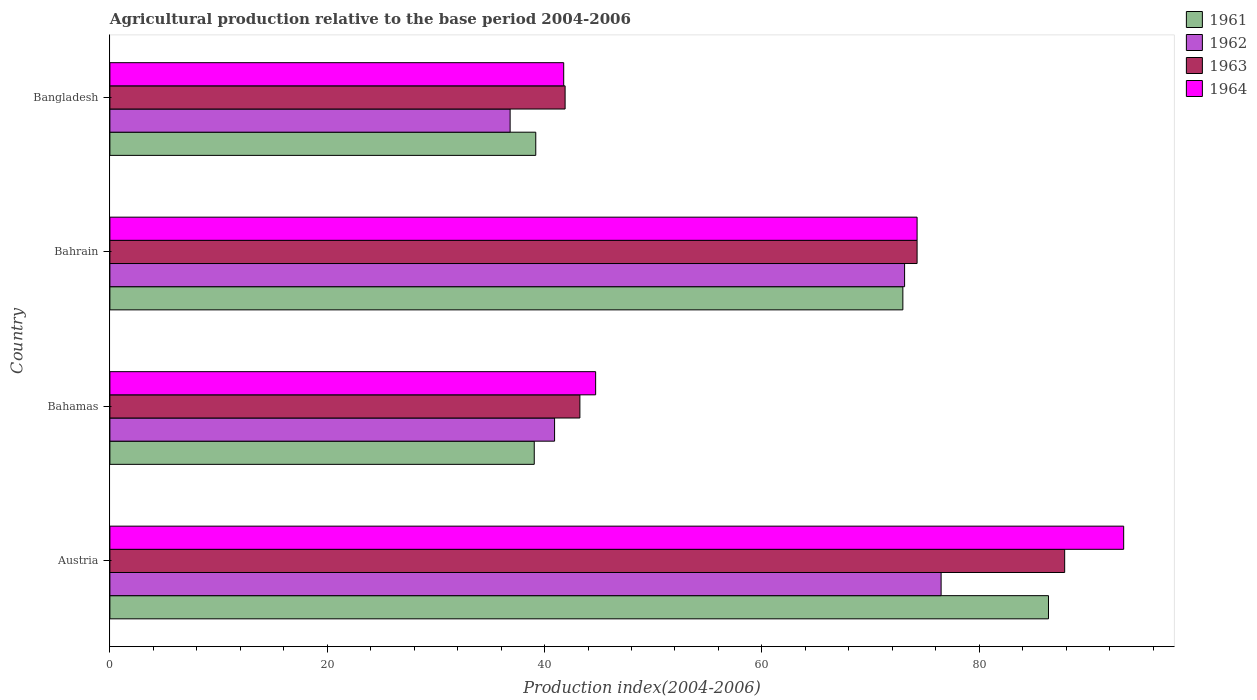How many different coloured bars are there?
Ensure brevity in your answer.  4. How many bars are there on the 4th tick from the top?
Offer a terse response. 4. What is the label of the 3rd group of bars from the top?
Give a very brief answer. Bahamas. In how many cases, is the number of bars for a given country not equal to the number of legend labels?
Make the answer very short. 0. What is the agricultural production index in 1963 in Bangladesh?
Provide a succinct answer. 41.89. Across all countries, what is the maximum agricultural production index in 1961?
Provide a succinct answer. 86.37. Across all countries, what is the minimum agricultural production index in 1964?
Provide a short and direct response. 41.76. In which country was the agricultural production index in 1963 maximum?
Offer a terse response. Austria. What is the total agricultural production index in 1964 in the graph?
Your answer should be very brief. 254.03. What is the difference between the agricultural production index in 1962 in Bahrain and that in Bangladesh?
Your answer should be very brief. 36.3. What is the difference between the agricultural production index in 1962 in Austria and the agricultural production index in 1963 in Bahamas?
Ensure brevity in your answer.  33.24. What is the average agricultural production index in 1962 per country?
Offer a terse response. 56.84. What is the difference between the agricultural production index in 1961 and agricultural production index in 1964 in Austria?
Provide a succinct answer. -6.92. What is the ratio of the agricultural production index in 1963 in Bahamas to that in Bahrain?
Offer a very short reply. 0.58. What is the difference between the highest and the second highest agricultural production index in 1961?
Provide a short and direct response. 13.4. What is the difference between the highest and the lowest agricultural production index in 1961?
Provide a succinct answer. 47.32. In how many countries, is the agricultural production index in 1963 greater than the average agricultural production index in 1963 taken over all countries?
Offer a terse response. 2. What does the 4th bar from the bottom in Bahrain represents?
Your answer should be compact. 1964. Does the graph contain any zero values?
Offer a very short reply. No. Where does the legend appear in the graph?
Your answer should be very brief. Top right. What is the title of the graph?
Give a very brief answer. Agricultural production relative to the base period 2004-2006. What is the label or title of the X-axis?
Provide a succinct answer. Production index(2004-2006). What is the label or title of the Y-axis?
Make the answer very short. Country. What is the Production index(2004-2006) in 1961 in Austria?
Offer a very short reply. 86.37. What is the Production index(2004-2006) in 1962 in Austria?
Offer a terse response. 76.49. What is the Production index(2004-2006) in 1963 in Austria?
Make the answer very short. 87.86. What is the Production index(2004-2006) of 1964 in Austria?
Offer a very short reply. 93.29. What is the Production index(2004-2006) of 1961 in Bahamas?
Give a very brief answer. 39.05. What is the Production index(2004-2006) of 1962 in Bahamas?
Ensure brevity in your answer.  40.92. What is the Production index(2004-2006) of 1963 in Bahamas?
Offer a terse response. 43.25. What is the Production index(2004-2006) of 1964 in Bahamas?
Provide a succinct answer. 44.7. What is the Production index(2004-2006) of 1961 in Bahrain?
Your answer should be very brief. 72.97. What is the Production index(2004-2006) in 1962 in Bahrain?
Provide a short and direct response. 73.13. What is the Production index(2004-2006) of 1963 in Bahrain?
Provide a short and direct response. 74.28. What is the Production index(2004-2006) in 1964 in Bahrain?
Your answer should be very brief. 74.28. What is the Production index(2004-2006) of 1961 in Bangladesh?
Provide a succinct answer. 39.19. What is the Production index(2004-2006) in 1962 in Bangladesh?
Make the answer very short. 36.83. What is the Production index(2004-2006) of 1963 in Bangladesh?
Your answer should be compact. 41.89. What is the Production index(2004-2006) of 1964 in Bangladesh?
Provide a short and direct response. 41.76. Across all countries, what is the maximum Production index(2004-2006) of 1961?
Provide a succinct answer. 86.37. Across all countries, what is the maximum Production index(2004-2006) in 1962?
Give a very brief answer. 76.49. Across all countries, what is the maximum Production index(2004-2006) of 1963?
Offer a very short reply. 87.86. Across all countries, what is the maximum Production index(2004-2006) in 1964?
Your response must be concise. 93.29. Across all countries, what is the minimum Production index(2004-2006) of 1961?
Provide a short and direct response. 39.05. Across all countries, what is the minimum Production index(2004-2006) of 1962?
Offer a very short reply. 36.83. Across all countries, what is the minimum Production index(2004-2006) in 1963?
Offer a terse response. 41.89. Across all countries, what is the minimum Production index(2004-2006) of 1964?
Provide a succinct answer. 41.76. What is the total Production index(2004-2006) of 1961 in the graph?
Provide a succinct answer. 237.58. What is the total Production index(2004-2006) in 1962 in the graph?
Your answer should be very brief. 227.37. What is the total Production index(2004-2006) in 1963 in the graph?
Give a very brief answer. 247.28. What is the total Production index(2004-2006) in 1964 in the graph?
Offer a terse response. 254.03. What is the difference between the Production index(2004-2006) of 1961 in Austria and that in Bahamas?
Ensure brevity in your answer.  47.32. What is the difference between the Production index(2004-2006) of 1962 in Austria and that in Bahamas?
Give a very brief answer. 35.57. What is the difference between the Production index(2004-2006) of 1963 in Austria and that in Bahamas?
Make the answer very short. 44.61. What is the difference between the Production index(2004-2006) in 1964 in Austria and that in Bahamas?
Your answer should be very brief. 48.59. What is the difference between the Production index(2004-2006) in 1962 in Austria and that in Bahrain?
Keep it short and to the point. 3.36. What is the difference between the Production index(2004-2006) in 1963 in Austria and that in Bahrain?
Make the answer very short. 13.58. What is the difference between the Production index(2004-2006) in 1964 in Austria and that in Bahrain?
Your response must be concise. 19.01. What is the difference between the Production index(2004-2006) of 1961 in Austria and that in Bangladesh?
Give a very brief answer. 47.18. What is the difference between the Production index(2004-2006) in 1962 in Austria and that in Bangladesh?
Give a very brief answer. 39.66. What is the difference between the Production index(2004-2006) of 1963 in Austria and that in Bangladesh?
Your answer should be very brief. 45.97. What is the difference between the Production index(2004-2006) in 1964 in Austria and that in Bangladesh?
Ensure brevity in your answer.  51.53. What is the difference between the Production index(2004-2006) in 1961 in Bahamas and that in Bahrain?
Keep it short and to the point. -33.92. What is the difference between the Production index(2004-2006) of 1962 in Bahamas and that in Bahrain?
Provide a short and direct response. -32.21. What is the difference between the Production index(2004-2006) of 1963 in Bahamas and that in Bahrain?
Your answer should be very brief. -31.03. What is the difference between the Production index(2004-2006) of 1964 in Bahamas and that in Bahrain?
Your answer should be compact. -29.58. What is the difference between the Production index(2004-2006) in 1961 in Bahamas and that in Bangladesh?
Offer a very short reply. -0.14. What is the difference between the Production index(2004-2006) in 1962 in Bahamas and that in Bangladesh?
Provide a short and direct response. 4.09. What is the difference between the Production index(2004-2006) of 1963 in Bahamas and that in Bangladesh?
Make the answer very short. 1.36. What is the difference between the Production index(2004-2006) in 1964 in Bahamas and that in Bangladesh?
Your response must be concise. 2.94. What is the difference between the Production index(2004-2006) in 1961 in Bahrain and that in Bangladesh?
Your answer should be compact. 33.78. What is the difference between the Production index(2004-2006) in 1962 in Bahrain and that in Bangladesh?
Offer a very short reply. 36.3. What is the difference between the Production index(2004-2006) in 1963 in Bahrain and that in Bangladesh?
Offer a very short reply. 32.39. What is the difference between the Production index(2004-2006) of 1964 in Bahrain and that in Bangladesh?
Offer a terse response. 32.52. What is the difference between the Production index(2004-2006) of 1961 in Austria and the Production index(2004-2006) of 1962 in Bahamas?
Offer a very short reply. 45.45. What is the difference between the Production index(2004-2006) in 1961 in Austria and the Production index(2004-2006) in 1963 in Bahamas?
Offer a terse response. 43.12. What is the difference between the Production index(2004-2006) of 1961 in Austria and the Production index(2004-2006) of 1964 in Bahamas?
Provide a succinct answer. 41.67. What is the difference between the Production index(2004-2006) of 1962 in Austria and the Production index(2004-2006) of 1963 in Bahamas?
Ensure brevity in your answer.  33.24. What is the difference between the Production index(2004-2006) in 1962 in Austria and the Production index(2004-2006) in 1964 in Bahamas?
Your response must be concise. 31.79. What is the difference between the Production index(2004-2006) of 1963 in Austria and the Production index(2004-2006) of 1964 in Bahamas?
Ensure brevity in your answer.  43.16. What is the difference between the Production index(2004-2006) in 1961 in Austria and the Production index(2004-2006) in 1962 in Bahrain?
Your answer should be very brief. 13.24. What is the difference between the Production index(2004-2006) in 1961 in Austria and the Production index(2004-2006) in 1963 in Bahrain?
Offer a terse response. 12.09. What is the difference between the Production index(2004-2006) of 1961 in Austria and the Production index(2004-2006) of 1964 in Bahrain?
Give a very brief answer. 12.09. What is the difference between the Production index(2004-2006) in 1962 in Austria and the Production index(2004-2006) in 1963 in Bahrain?
Your response must be concise. 2.21. What is the difference between the Production index(2004-2006) of 1962 in Austria and the Production index(2004-2006) of 1964 in Bahrain?
Give a very brief answer. 2.21. What is the difference between the Production index(2004-2006) of 1963 in Austria and the Production index(2004-2006) of 1964 in Bahrain?
Your response must be concise. 13.58. What is the difference between the Production index(2004-2006) of 1961 in Austria and the Production index(2004-2006) of 1962 in Bangladesh?
Provide a succinct answer. 49.54. What is the difference between the Production index(2004-2006) of 1961 in Austria and the Production index(2004-2006) of 1963 in Bangladesh?
Keep it short and to the point. 44.48. What is the difference between the Production index(2004-2006) of 1961 in Austria and the Production index(2004-2006) of 1964 in Bangladesh?
Offer a very short reply. 44.61. What is the difference between the Production index(2004-2006) of 1962 in Austria and the Production index(2004-2006) of 1963 in Bangladesh?
Keep it short and to the point. 34.6. What is the difference between the Production index(2004-2006) of 1962 in Austria and the Production index(2004-2006) of 1964 in Bangladesh?
Give a very brief answer. 34.73. What is the difference between the Production index(2004-2006) in 1963 in Austria and the Production index(2004-2006) in 1964 in Bangladesh?
Offer a very short reply. 46.1. What is the difference between the Production index(2004-2006) in 1961 in Bahamas and the Production index(2004-2006) in 1962 in Bahrain?
Offer a terse response. -34.08. What is the difference between the Production index(2004-2006) in 1961 in Bahamas and the Production index(2004-2006) in 1963 in Bahrain?
Keep it short and to the point. -35.23. What is the difference between the Production index(2004-2006) in 1961 in Bahamas and the Production index(2004-2006) in 1964 in Bahrain?
Offer a very short reply. -35.23. What is the difference between the Production index(2004-2006) of 1962 in Bahamas and the Production index(2004-2006) of 1963 in Bahrain?
Your answer should be very brief. -33.36. What is the difference between the Production index(2004-2006) in 1962 in Bahamas and the Production index(2004-2006) in 1964 in Bahrain?
Offer a terse response. -33.36. What is the difference between the Production index(2004-2006) of 1963 in Bahamas and the Production index(2004-2006) of 1964 in Bahrain?
Ensure brevity in your answer.  -31.03. What is the difference between the Production index(2004-2006) of 1961 in Bahamas and the Production index(2004-2006) of 1962 in Bangladesh?
Provide a succinct answer. 2.22. What is the difference between the Production index(2004-2006) in 1961 in Bahamas and the Production index(2004-2006) in 1963 in Bangladesh?
Make the answer very short. -2.84. What is the difference between the Production index(2004-2006) of 1961 in Bahamas and the Production index(2004-2006) of 1964 in Bangladesh?
Make the answer very short. -2.71. What is the difference between the Production index(2004-2006) of 1962 in Bahamas and the Production index(2004-2006) of 1963 in Bangladesh?
Give a very brief answer. -0.97. What is the difference between the Production index(2004-2006) of 1962 in Bahamas and the Production index(2004-2006) of 1964 in Bangladesh?
Offer a very short reply. -0.84. What is the difference between the Production index(2004-2006) in 1963 in Bahamas and the Production index(2004-2006) in 1964 in Bangladesh?
Offer a very short reply. 1.49. What is the difference between the Production index(2004-2006) of 1961 in Bahrain and the Production index(2004-2006) of 1962 in Bangladesh?
Your answer should be compact. 36.14. What is the difference between the Production index(2004-2006) in 1961 in Bahrain and the Production index(2004-2006) in 1963 in Bangladesh?
Your response must be concise. 31.08. What is the difference between the Production index(2004-2006) of 1961 in Bahrain and the Production index(2004-2006) of 1964 in Bangladesh?
Your response must be concise. 31.21. What is the difference between the Production index(2004-2006) of 1962 in Bahrain and the Production index(2004-2006) of 1963 in Bangladesh?
Offer a very short reply. 31.24. What is the difference between the Production index(2004-2006) of 1962 in Bahrain and the Production index(2004-2006) of 1964 in Bangladesh?
Provide a succinct answer. 31.37. What is the difference between the Production index(2004-2006) of 1963 in Bahrain and the Production index(2004-2006) of 1964 in Bangladesh?
Ensure brevity in your answer.  32.52. What is the average Production index(2004-2006) of 1961 per country?
Your answer should be compact. 59.4. What is the average Production index(2004-2006) in 1962 per country?
Your answer should be very brief. 56.84. What is the average Production index(2004-2006) of 1963 per country?
Give a very brief answer. 61.82. What is the average Production index(2004-2006) in 1964 per country?
Your answer should be compact. 63.51. What is the difference between the Production index(2004-2006) of 1961 and Production index(2004-2006) of 1962 in Austria?
Ensure brevity in your answer.  9.88. What is the difference between the Production index(2004-2006) in 1961 and Production index(2004-2006) in 1963 in Austria?
Ensure brevity in your answer.  -1.49. What is the difference between the Production index(2004-2006) in 1961 and Production index(2004-2006) in 1964 in Austria?
Provide a succinct answer. -6.92. What is the difference between the Production index(2004-2006) of 1962 and Production index(2004-2006) of 1963 in Austria?
Provide a succinct answer. -11.37. What is the difference between the Production index(2004-2006) in 1962 and Production index(2004-2006) in 1964 in Austria?
Keep it short and to the point. -16.8. What is the difference between the Production index(2004-2006) in 1963 and Production index(2004-2006) in 1964 in Austria?
Offer a very short reply. -5.43. What is the difference between the Production index(2004-2006) of 1961 and Production index(2004-2006) of 1962 in Bahamas?
Ensure brevity in your answer.  -1.87. What is the difference between the Production index(2004-2006) of 1961 and Production index(2004-2006) of 1963 in Bahamas?
Provide a succinct answer. -4.2. What is the difference between the Production index(2004-2006) in 1961 and Production index(2004-2006) in 1964 in Bahamas?
Your answer should be very brief. -5.65. What is the difference between the Production index(2004-2006) of 1962 and Production index(2004-2006) of 1963 in Bahamas?
Your answer should be compact. -2.33. What is the difference between the Production index(2004-2006) of 1962 and Production index(2004-2006) of 1964 in Bahamas?
Offer a very short reply. -3.78. What is the difference between the Production index(2004-2006) of 1963 and Production index(2004-2006) of 1964 in Bahamas?
Offer a terse response. -1.45. What is the difference between the Production index(2004-2006) in 1961 and Production index(2004-2006) in 1962 in Bahrain?
Provide a short and direct response. -0.16. What is the difference between the Production index(2004-2006) in 1961 and Production index(2004-2006) in 1963 in Bahrain?
Your answer should be very brief. -1.31. What is the difference between the Production index(2004-2006) in 1961 and Production index(2004-2006) in 1964 in Bahrain?
Make the answer very short. -1.31. What is the difference between the Production index(2004-2006) in 1962 and Production index(2004-2006) in 1963 in Bahrain?
Your answer should be compact. -1.15. What is the difference between the Production index(2004-2006) of 1962 and Production index(2004-2006) of 1964 in Bahrain?
Offer a very short reply. -1.15. What is the difference between the Production index(2004-2006) in 1963 and Production index(2004-2006) in 1964 in Bahrain?
Offer a terse response. 0. What is the difference between the Production index(2004-2006) of 1961 and Production index(2004-2006) of 1962 in Bangladesh?
Offer a very short reply. 2.36. What is the difference between the Production index(2004-2006) of 1961 and Production index(2004-2006) of 1963 in Bangladesh?
Make the answer very short. -2.7. What is the difference between the Production index(2004-2006) of 1961 and Production index(2004-2006) of 1964 in Bangladesh?
Offer a terse response. -2.57. What is the difference between the Production index(2004-2006) in 1962 and Production index(2004-2006) in 1963 in Bangladesh?
Provide a short and direct response. -5.06. What is the difference between the Production index(2004-2006) in 1962 and Production index(2004-2006) in 1964 in Bangladesh?
Keep it short and to the point. -4.93. What is the difference between the Production index(2004-2006) in 1963 and Production index(2004-2006) in 1964 in Bangladesh?
Your response must be concise. 0.13. What is the ratio of the Production index(2004-2006) in 1961 in Austria to that in Bahamas?
Offer a very short reply. 2.21. What is the ratio of the Production index(2004-2006) in 1962 in Austria to that in Bahamas?
Ensure brevity in your answer.  1.87. What is the ratio of the Production index(2004-2006) in 1963 in Austria to that in Bahamas?
Keep it short and to the point. 2.03. What is the ratio of the Production index(2004-2006) of 1964 in Austria to that in Bahamas?
Your answer should be very brief. 2.09. What is the ratio of the Production index(2004-2006) in 1961 in Austria to that in Bahrain?
Offer a very short reply. 1.18. What is the ratio of the Production index(2004-2006) in 1962 in Austria to that in Bahrain?
Offer a very short reply. 1.05. What is the ratio of the Production index(2004-2006) of 1963 in Austria to that in Bahrain?
Provide a succinct answer. 1.18. What is the ratio of the Production index(2004-2006) in 1964 in Austria to that in Bahrain?
Give a very brief answer. 1.26. What is the ratio of the Production index(2004-2006) in 1961 in Austria to that in Bangladesh?
Keep it short and to the point. 2.2. What is the ratio of the Production index(2004-2006) in 1962 in Austria to that in Bangladesh?
Provide a short and direct response. 2.08. What is the ratio of the Production index(2004-2006) of 1963 in Austria to that in Bangladesh?
Your answer should be very brief. 2.1. What is the ratio of the Production index(2004-2006) in 1964 in Austria to that in Bangladesh?
Your answer should be very brief. 2.23. What is the ratio of the Production index(2004-2006) of 1961 in Bahamas to that in Bahrain?
Offer a terse response. 0.54. What is the ratio of the Production index(2004-2006) in 1962 in Bahamas to that in Bahrain?
Your response must be concise. 0.56. What is the ratio of the Production index(2004-2006) of 1963 in Bahamas to that in Bahrain?
Offer a terse response. 0.58. What is the ratio of the Production index(2004-2006) in 1964 in Bahamas to that in Bahrain?
Offer a very short reply. 0.6. What is the ratio of the Production index(2004-2006) in 1962 in Bahamas to that in Bangladesh?
Your response must be concise. 1.11. What is the ratio of the Production index(2004-2006) in 1963 in Bahamas to that in Bangladesh?
Offer a terse response. 1.03. What is the ratio of the Production index(2004-2006) of 1964 in Bahamas to that in Bangladesh?
Offer a terse response. 1.07. What is the ratio of the Production index(2004-2006) in 1961 in Bahrain to that in Bangladesh?
Offer a very short reply. 1.86. What is the ratio of the Production index(2004-2006) of 1962 in Bahrain to that in Bangladesh?
Give a very brief answer. 1.99. What is the ratio of the Production index(2004-2006) of 1963 in Bahrain to that in Bangladesh?
Provide a succinct answer. 1.77. What is the ratio of the Production index(2004-2006) in 1964 in Bahrain to that in Bangladesh?
Your answer should be very brief. 1.78. What is the difference between the highest and the second highest Production index(2004-2006) of 1961?
Make the answer very short. 13.4. What is the difference between the highest and the second highest Production index(2004-2006) in 1962?
Offer a terse response. 3.36. What is the difference between the highest and the second highest Production index(2004-2006) of 1963?
Provide a succinct answer. 13.58. What is the difference between the highest and the second highest Production index(2004-2006) of 1964?
Provide a short and direct response. 19.01. What is the difference between the highest and the lowest Production index(2004-2006) in 1961?
Provide a succinct answer. 47.32. What is the difference between the highest and the lowest Production index(2004-2006) in 1962?
Offer a terse response. 39.66. What is the difference between the highest and the lowest Production index(2004-2006) of 1963?
Give a very brief answer. 45.97. What is the difference between the highest and the lowest Production index(2004-2006) of 1964?
Ensure brevity in your answer.  51.53. 